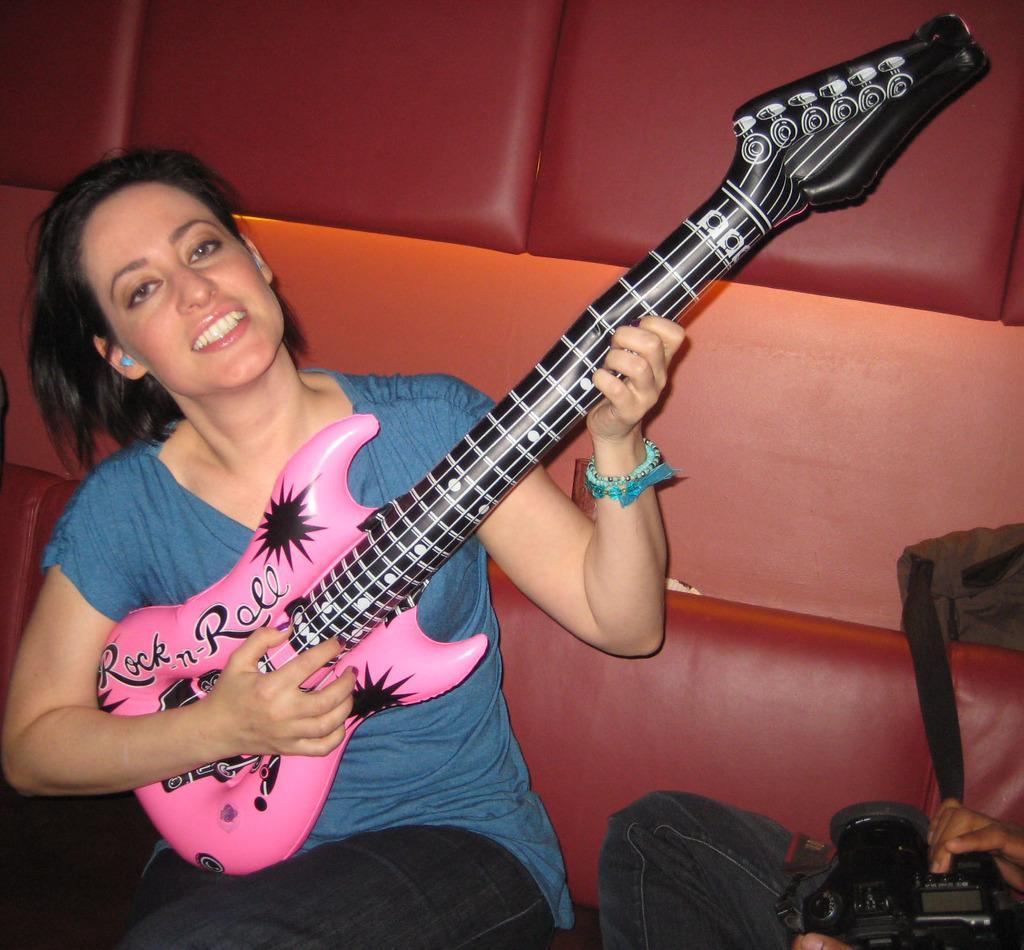Please provide a concise description of this image. In this image we can see a lady, musical instrument and other objects. In the background of the image there is a cushion wall. On the right side of the image it looks like a person and a camera. 